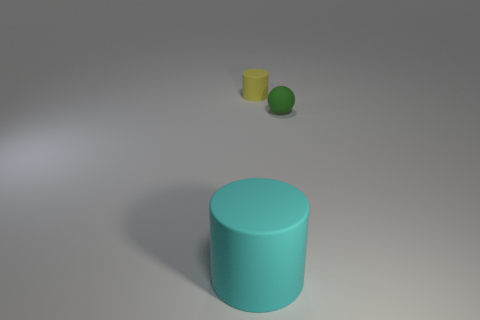What materials do the objects in the image seem to be made from? The objects appear to have different textures. The large turquoise cylinder seems to have a smooth, possibly plastic finish, while the small yellow object has a matte surface that might suggest a clay or unglazed ceramic material. The green sphere appears to have a glossy surface, indicating it could be made of glass or polished stone. 